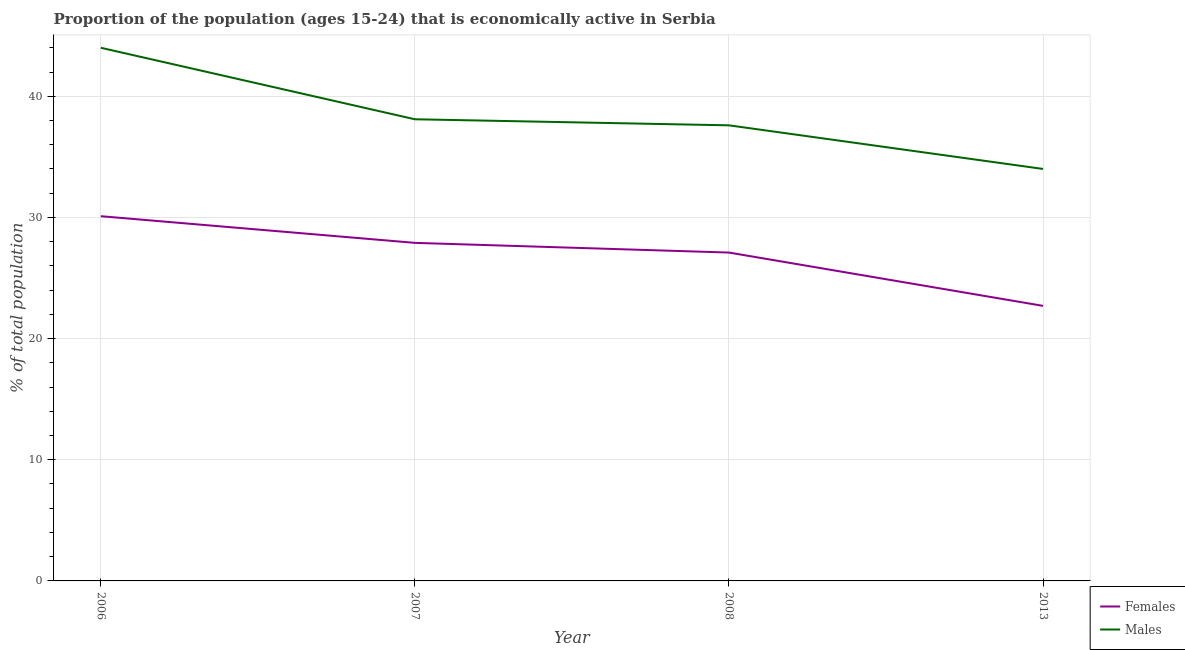Is the number of lines equal to the number of legend labels?
Ensure brevity in your answer.  Yes. What is the percentage of economically active male population in 2007?
Provide a short and direct response. 38.1. In which year was the percentage of economically active male population maximum?
Make the answer very short. 2006. In which year was the percentage of economically active female population minimum?
Make the answer very short. 2013. What is the total percentage of economically active male population in the graph?
Your answer should be compact. 153.7. What is the difference between the percentage of economically active male population in 2006 and that in 2013?
Your answer should be compact. 10. What is the difference between the percentage of economically active female population in 2013 and the percentage of economically active male population in 2007?
Offer a terse response. -15.4. What is the average percentage of economically active female population per year?
Your response must be concise. 26.95. In the year 2013, what is the difference between the percentage of economically active female population and percentage of economically active male population?
Provide a succinct answer. -11.3. What is the ratio of the percentage of economically active female population in 2006 to that in 2013?
Provide a succinct answer. 1.33. Is the difference between the percentage of economically active female population in 2006 and 2013 greater than the difference between the percentage of economically active male population in 2006 and 2013?
Your answer should be very brief. No. What is the difference between the highest and the second highest percentage of economically active female population?
Ensure brevity in your answer.  2.2. What is the difference between the highest and the lowest percentage of economically active female population?
Your answer should be compact. 7.4. In how many years, is the percentage of economically active female population greater than the average percentage of economically active female population taken over all years?
Your answer should be very brief. 3. Is the sum of the percentage of economically active male population in 2006 and 2008 greater than the maximum percentage of economically active female population across all years?
Keep it short and to the point. Yes. Does the percentage of economically active male population monotonically increase over the years?
Your answer should be compact. No. Is the percentage of economically active male population strictly greater than the percentage of economically active female population over the years?
Your response must be concise. Yes. Is the percentage of economically active female population strictly less than the percentage of economically active male population over the years?
Offer a very short reply. Yes. How many lines are there?
Make the answer very short. 2. How many years are there in the graph?
Offer a terse response. 4. What is the difference between two consecutive major ticks on the Y-axis?
Your answer should be very brief. 10. Are the values on the major ticks of Y-axis written in scientific E-notation?
Ensure brevity in your answer.  No. Where does the legend appear in the graph?
Offer a very short reply. Bottom right. How many legend labels are there?
Offer a terse response. 2. How are the legend labels stacked?
Keep it short and to the point. Vertical. What is the title of the graph?
Ensure brevity in your answer.  Proportion of the population (ages 15-24) that is economically active in Serbia. What is the label or title of the Y-axis?
Keep it short and to the point. % of total population. What is the % of total population in Females in 2006?
Your answer should be compact. 30.1. What is the % of total population of Males in 2006?
Provide a short and direct response. 44. What is the % of total population in Females in 2007?
Your response must be concise. 27.9. What is the % of total population of Males in 2007?
Give a very brief answer. 38.1. What is the % of total population of Females in 2008?
Provide a succinct answer. 27.1. What is the % of total population in Males in 2008?
Your answer should be compact. 37.6. What is the % of total population in Females in 2013?
Your answer should be very brief. 22.7. Across all years, what is the maximum % of total population in Females?
Provide a short and direct response. 30.1. Across all years, what is the minimum % of total population in Females?
Offer a terse response. 22.7. What is the total % of total population in Females in the graph?
Offer a very short reply. 107.8. What is the total % of total population of Males in the graph?
Offer a terse response. 153.7. What is the difference between the % of total population in Females in 2006 and that in 2008?
Provide a short and direct response. 3. What is the difference between the % of total population in Females in 2007 and that in 2008?
Ensure brevity in your answer.  0.8. What is the difference between the % of total population of Males in 2007 and that in 2013?
Give a very brief answer. 4.1. What is the difference between the % of total population of Females in 2007 and the % of total population of Males in 2008?
Provide a short and direct response. -9.7. What is the difference between the % of total population of Females in 2007 and the % of total population of Males in 2013?
Your answer should be compact. -6.1. What is the difference between the % of total population of Females in 2008 and the % of total population of Males in 2013?
Your response must be concise. -6.9. What is the average % of total population of Females per year?
Ensure brevity in your answer.  26.95. What is the average % of total population in Males per year?
Your answer should be very brief. 38.42. In the year 2013, what is the difference between the % of total population of Females and % of total population of Males?
Give a very brief answer. -11.3. What is the ratio of the % of total population of Females in 2006 to that in 2007?
Make the answer very short. 1.08. What is the ratio of the % of total population in Males in 2006 to that in 2007?
Offer a very short reply. 1.15. What is the ratio of the % of total population of Females in 2006 to that in 2008?
Your response must be concise. 1.11. What is the ratio of the % of total population of Males in 2006 to that in 2008?
Make the answer very short. 1.17. What is the ratio of the % of total population in Females in 2006 to that in 2013?
Provide a succinct answer. 1.33. What is the ratio of the % of total population in Males in 2006 to that in 2013?
Provide a short and direct response. 1.29. What is the ratio of the % of total population in Females in 2007 to that in 2008?
Give a very brief answer. 1.03. What is the ratio of the % of total population in Males in 2007 to that in 2008?
Make the answer very short. 1.01. What is the ratio of the % of total population of Females in 2007 to that in 2013?
Ensure brevity in your answer.  1.23. What is the ratio of the % of total population of Males in 2007 to that in 2013?
Ensure brevity in your answer.  1.12. What is the ratio of the % of total population in Females in 2008 to that in 2013?
Ensure brevity in your answer.  1.19. What is the ratio of the % of total population in Males in 2008 to that in 2013?
Offer a terse response. 1.11. What is the difference between the highest and the second highest % of total population of Males?
Your answer should be compact. 5.9. 